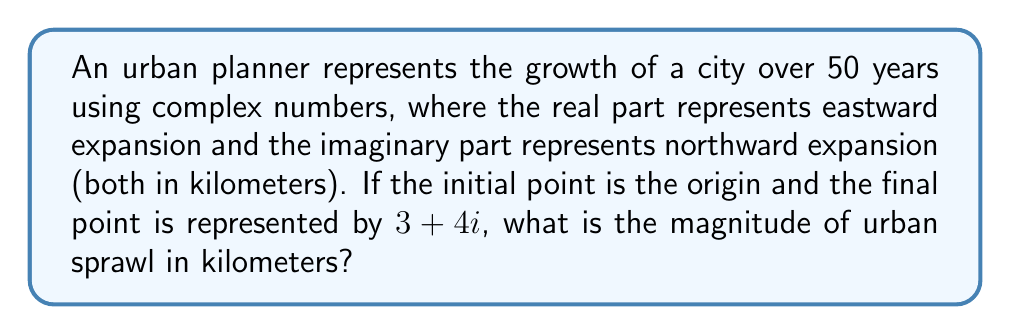Can you solve this math problem? To find the magnitude of urban sprawl using complex number representation, we need to calculate the absolute value (or modulus) of the complex number representing the city's growth.

Step 1: Identify the complex number
The city's growth is represented by $z = 3 + 4i$

Step 2: Use the formula for the magnitude of a complex number
For a complex number $a + bi$, the magnitude is given by:
$$|z| = \sqrt{a^2 + b^2}$$

Step 3: Substitute the values
$$|z| = \sqrt{3^2 + 4^2}$$

Step 4: Calculate
$$|z| = \sqrt{9 + 16} = \sqrt{25} = 5$$

The magnitude of urban sprawl is 5 kilometers.

This result represents the straight-line distance between the initial point (origin) and the final point of urban growth, taking into account both eastward and northward expansion.
Answer: $5$ km 